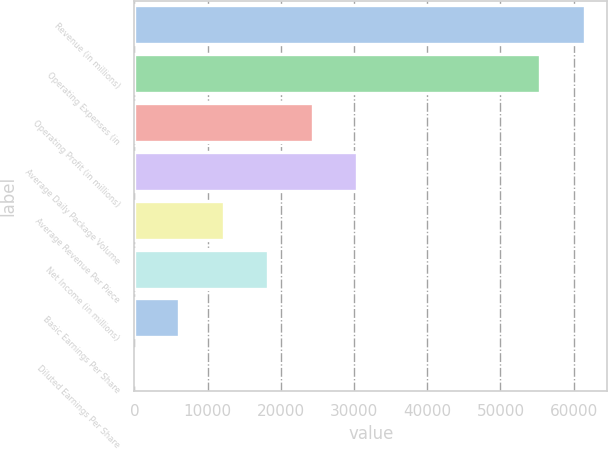<chart> <loc_0><loc_0><loc_500><loc_500><bar_chart><fcel>Revenue (in millions)<fcel>Operating Expenses (in<fcel>Operating Profit (in millions)<fcel>Average Daily Package Volume<fcel>Average Revenue Per Piece<fcel>Net Income (in millions)<fcel>Basic Earnings Per Share<fcel>Diluted Earnings Per Share<nl><fcel>61529.2<fcel>55439<fcel>24364.7<fcel>30454.9<fcel>12184.3<fcel>18274.5<fcel>6094.08<fcel>3.87<nl></chart> 